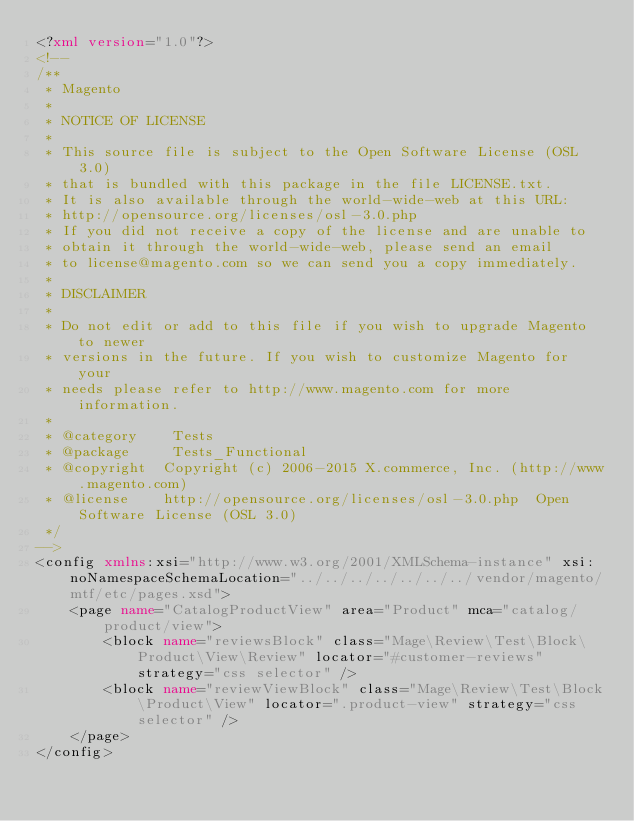<code> <loc_0><loc_0><loc_500><loc_500><_XML_><?xml version="1.0"?>
<!--
/**
 * Magento
 *
 * NOTICE OF LICENSE
 *
 * This source file is subject to the Open Software License (OSL 3.0)
 * that is bundled with this package in the file LICENSE.txt.
 * It is also available through the world-wide-web at this URL:
 * http://opensource.org/licenses/osl-3.0.php
 * If you did not receive a copy of the license and are unable to
 * obtain it through the world-wide-web, please send an email
 * to license@magento.com so we can send you a copy immediately.
 *
 * DISCLAIMER
 *
 * Do not edit or add to this file if you wish to upgrade Magento to newer
 * versions in the future. If you wish to customize Magento for your
 * needs please refer to http://www.magento.com for more information.
 *
 * @category    Tests
 * @package     Tests_Functional
 * @copyright  Copyright (c) 2006-2015 X.commerce, Inc. (http://www.magento.com)
 * @license    http://opensource.org/licenses/osl-3.0.php  Open Software License (OSL 3.0)
 */
-->
<config xmlns:xsi="http://www.w3.org/2001/XMLSchema-instance" xsi:noNamespaceSchemaLocation="../../../../../../../vendor/magento/mtf/etc/pages.xsd">
    <page name="CatalogProductView" area="Product" mca="catalog/product/view">
        <block name="reviewsBlock" class="Mage\Review\Test\Block\Product\View\Review" locator="#customer-reviews" strategy="css selector" />
        <block name="reviewViewBlock" class="Mage\Review\Test\Block\Product\View" locator=".product-view" strategy="css selector" />
    </page>
</config>
</code> 